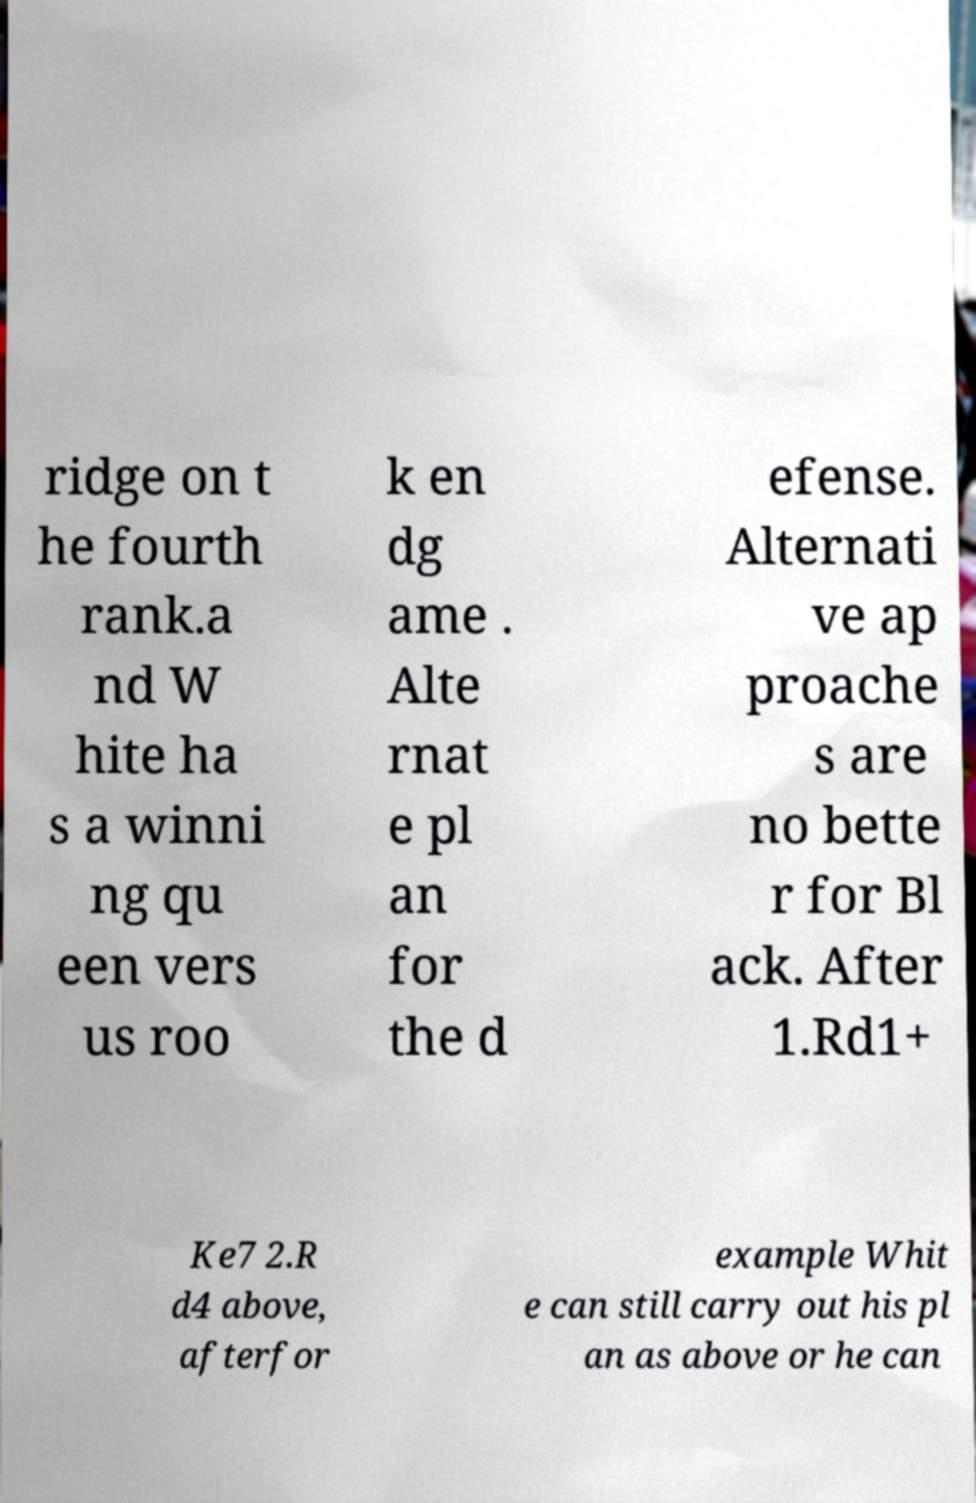For documentation purposes, I need the text within this image transcribed. Could you provide that? ridge on t he fourth rank.a nd W hite ha s a winni ng qu een vers us roo k en dg ame . Alte rnat e pl an for the d efense. Alternati ve ap proache s are no bette r for Bl ack. After 1.Rd1+ Ke7 2.R d4 above, afterfor example Whit e can still carry out his pl an as above or he can 